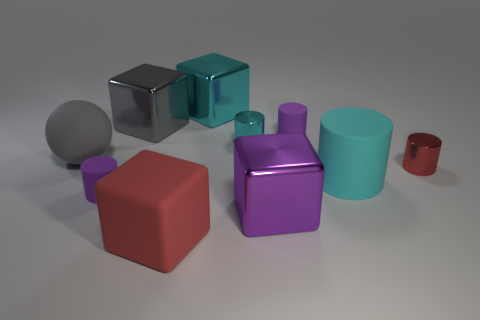Subtract 2 cylinders. How many cylinders are left? 3 Subtract all purple cylinders. Subtract all red blocks. How many cylinders are left? 3 Subtract all balls. How many objects are left? 9 Add 2 large purple things. How many large purple things are left? 3 Add 10 green metallic cylinders. How many green metallic cylinders exist? 10 Subtract 0 brown spheres. How many objects are left? 10 Subtract all small purple metallic balls. Subtract all rubber cubes. How many objects are left? 9 